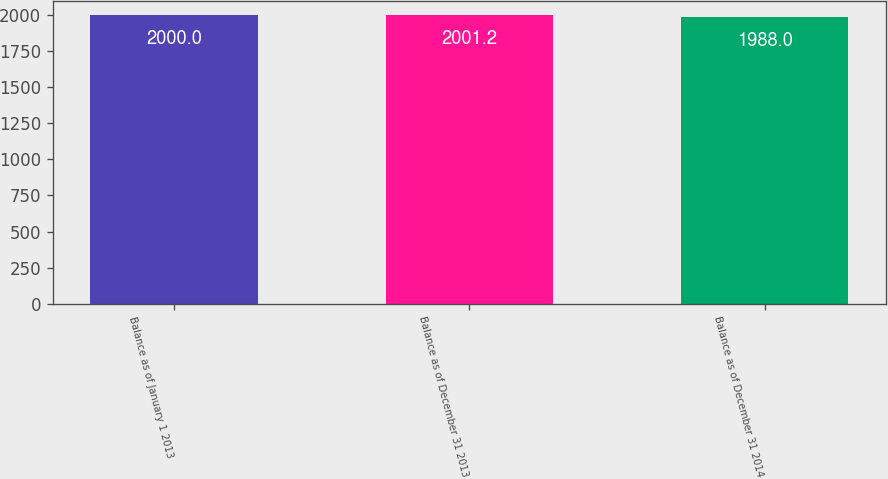Convert chart to OTSL. <chart><loc_0><loc_0><loc_500><loc_500><bar_chart><fcel>Balance as of January 1 2013<fcel>Balance as of December 31 2013<fcel>Balance as of December 31 2014<nl><fcel>2000<fcel>2001.2<fcel>1988<nl></chart> 